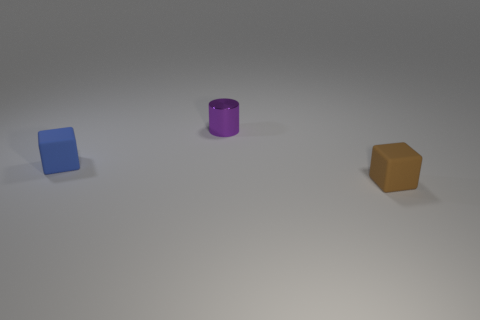Is there another big brown object of the same shape as the brown object?
Give a very brief answer. No. How many things are yellow rubber cylinders or small things that are on the right side of the purple shiny cylinder?
Your answer should be compact. 1. What number of other objects are the same material as the tiny purple object?
Your response must be concise. 0. What number of things are tiny blue matte blocks or blue matte cylinders?
Your answer should be compact. 1. Are there more small purple shiny cylinders that are behind the blue cube than blue objects to the right of the brown object?
Provide a succinct answer. Yes. Do the tiny object that is left of the purple object and the rubber object that is right of the tiny blue matte block have the same color?
Your answer should be very brief. No. How big is the object behind the tiny rubber object that is behind the small rubber cube that is on the right side of the shiny thing?
Offer a terse response. Small. What is the color of the other tiny matte thing that is the same shape as the brown matte object?
Provide a succinct answer. Blue. Is the number of cylinders in front of the tiny cylinder greater than the number of small purple metal objects?
Your response must be concise. No. Does the tiny blue thing have the same shape as the matte thing that is in front of the tiny blue matte thing?
Provide a short and direct response. Yes. 